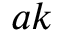<formula> <loc_0><loc_0><loc_500><loc_500>a k</formula> 